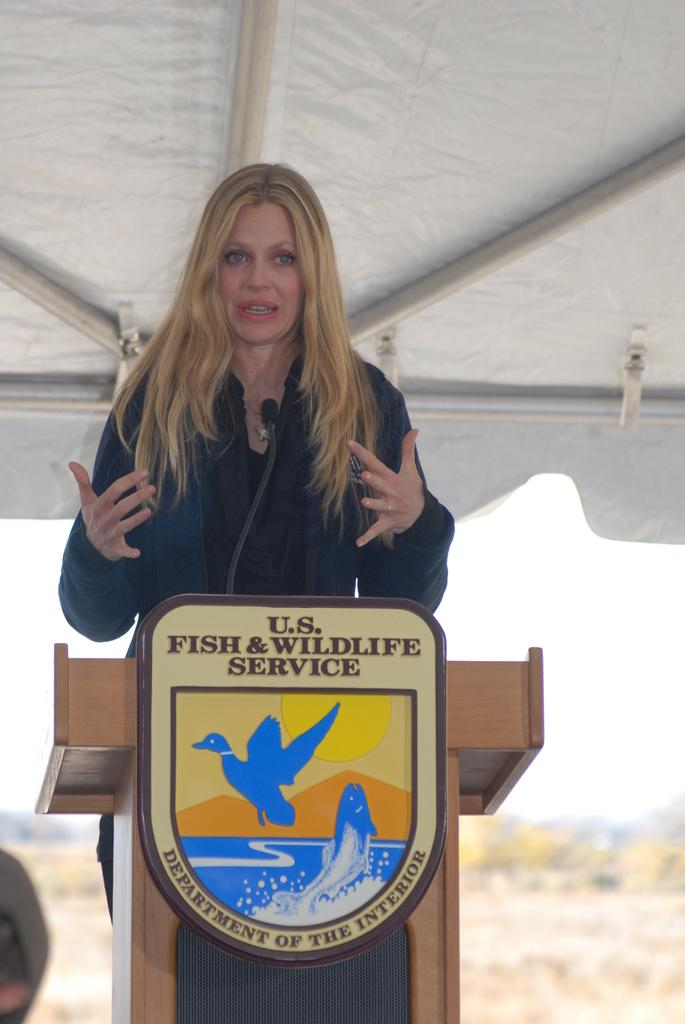<image>
Give a short and clear explanation of the subsequent image. Woman giving a presentation behind a podium that says Fish & WIldlife Service. 